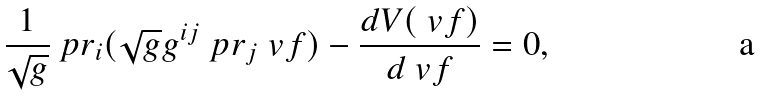<formula> <loc_0><loc_0><loc_500><loc_500>\frac { 1 } { \sqrt { g } } \ p r _ { i } ( \sqrt { g } g ^ { i j } \ p r _ { j } \ v f ) - \frac { d V ( \ v f ) } { d \ v f } = 0 ,</formula> 